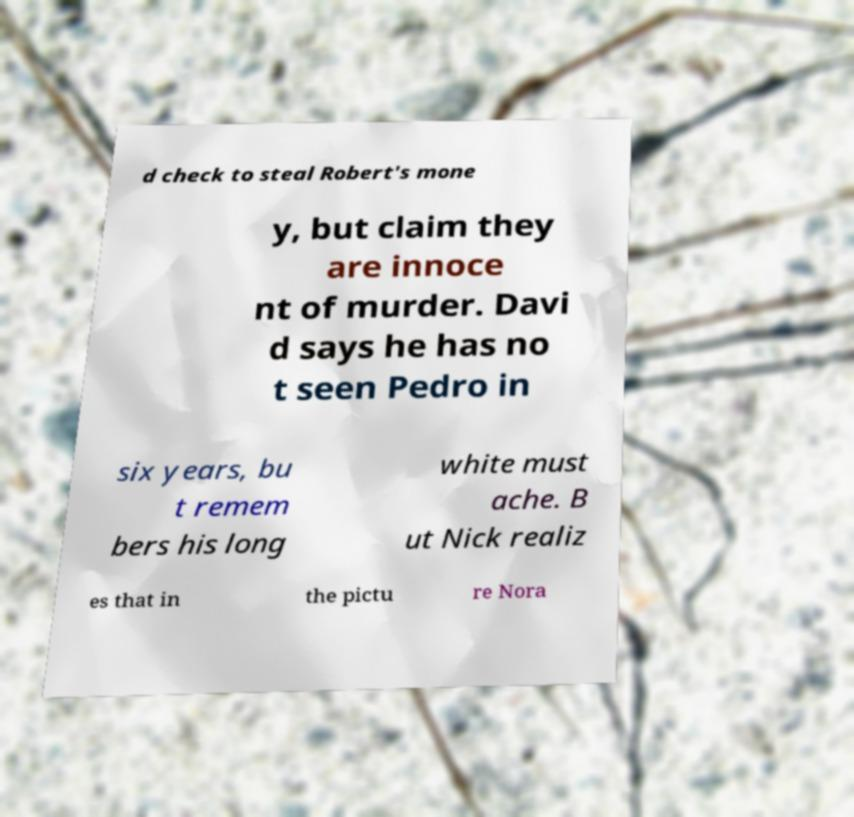I need the written content from this picture converted into text. Can you do that? d check to steal Robert's mone y, but claim they are innoce nt of murder. Davi d says he has no t seen Pedro in six years, bu t remem bers his long white must ache. B ut Nick realiz es that in the pictu re Nora 